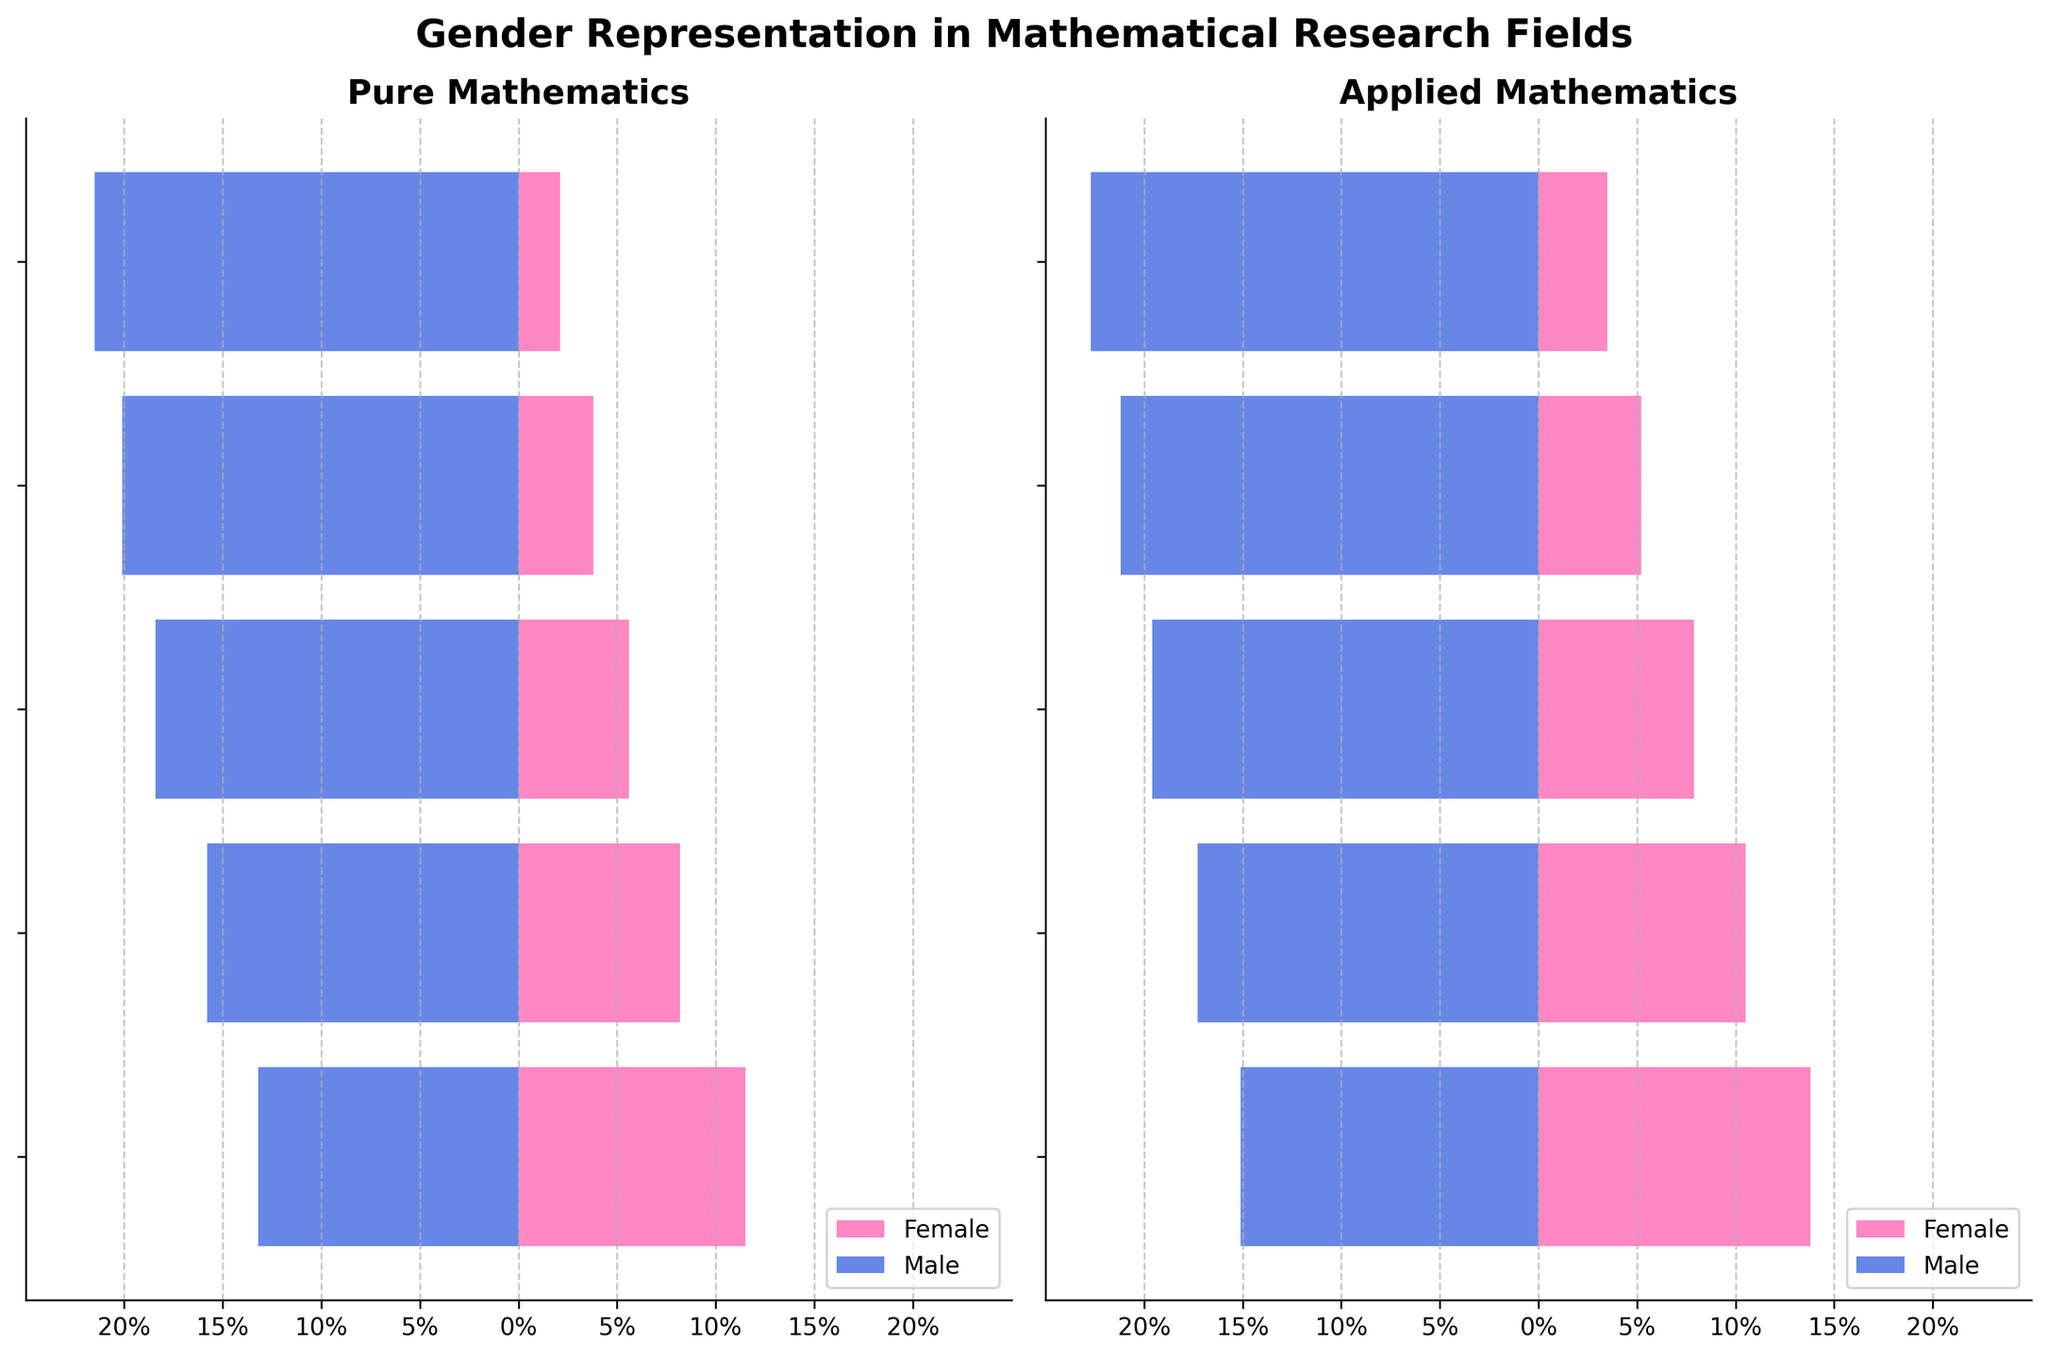What is the title of the plot? The title of the plot is prominently displayed at the top center of the figure. It provides the context of what the plot is about.
Answer: Gender Representation in Mathematical Research Fields What color represents females in the plot? The color used for females can be identified by looking at the legend on the bottom right corner of each subplot.
Answer: Pink What age group has the highest representation in Pure Mathematics for males? Look at the Pure Mathematics subplot on the left and identify the bar (blue in color) with the largest magnitude for males across different age groups.
Answer: 60+ Compare the female representation in the 40-49 age group between Pure and Applied Mathematics. Find the 40-49 age group on both subplots; compare the lengths of the pink bars for this age group. Note that the values can be read directly from the end of the bars.
Answer: Applied Mathematics has higher representation Between which two age groups is the difference in female representation the greatest in Applied Mathematics? Examine the Applied Mathematics subplot and measure the largest absolute difference in the pink bar lengths between consecutive age groups for females.
Answer: 50-59 and 60+ What is the total percentage of male representation in Pure Mathematics across all age groups? Sum the absolute values of all the blue bar lengths (negative values) in the Pure Mathematics subplot to get the total percentage for males.
Answer: 89 Compare the overall trend of female representation across age groups within each field. Identify the overall pattern of the pink bars in both subplots—whether they increase or decrease as age progresses. This aids in understanding the overall trend within each field.
Answer: Both fields show a decreasing trend as age increases What is the range of male representation in the 30-39 age group between Pure and Applied Mathematics? Find the 30-39 age group for males in both subplots and compute the difference between their absolute values.
Answer: 1.5 Which age group has the most significant disparity in gender representation in Pure Mathematics? For the Pure Mathematics subplot, compare the absolute values of the pink and blue bars within each age group to find the greatest difference.
Answer: 60+ How does the gender representation in the 20-29 age group differ between Pure and Applied Mathematics? Compare the pink and blue bars for the 20-29 age group across both subplots to identify differences in lengths.
Answer: Applied Mathematics has more balanced representation between genders 